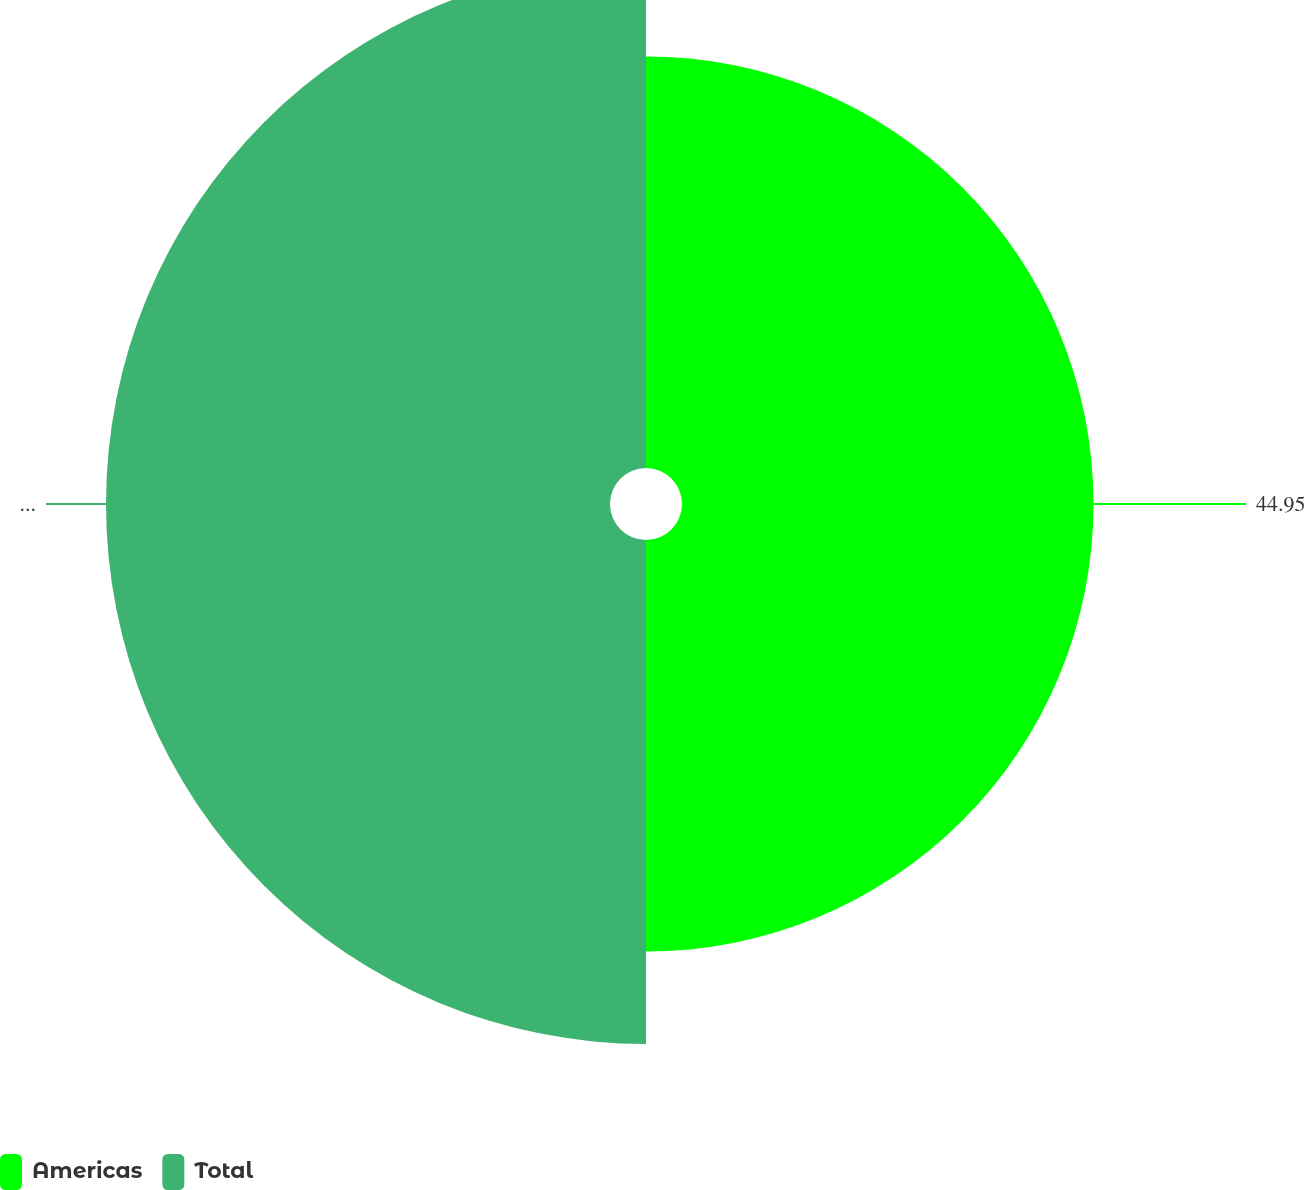<chart> <loc_0><loc_0><loc_500><loc_500><pie_chart><fcel>Americas<fcel>Total<nl><fcel>44.95%<fcel>55.05%<nl></chart> 